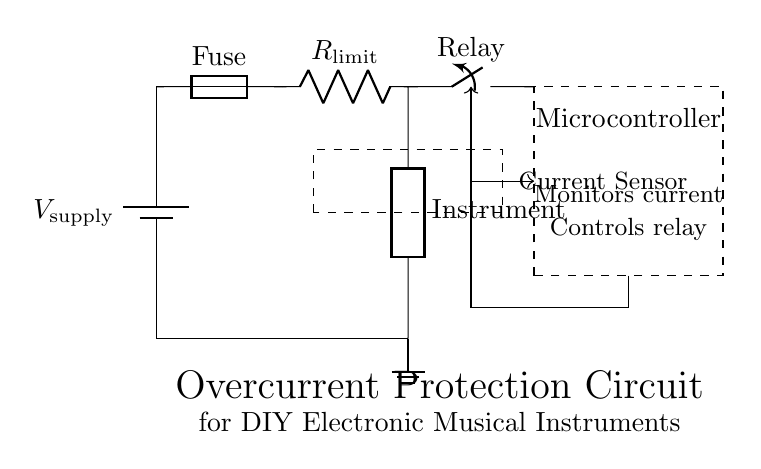What component is used for overcurrent protection? The component used for overcurrent protection in this circuit is a fuse. It is designed to blow when the current exceeds a certain limit, thus protecting the downstream components from excessive current.
Answer: Fuse What is the purpose of the current-limiting resistor? The purpose of the current-limiting resistor is to restrict the amount of current that can flow through the circuit, thereby preventing damage to the connected instrument during normal operation.
Answer: Restrict current Which component monitors the current in the circuit? The component that monitors the current in the circuit is the microcontroller. It receives data from the current sensor and can make decisions based on that data, such as operating the relay.
Answer: Microcontroller What is the role of the relay in this circuit? The relay acts as a switch that can disconnect the circuit from the supply voltage when an overcurrent condition is detected. This is controlled by the microcontroller, which receives inputs from the current sensor.
Answer: Switch How is the microcontroller powered? The microcontroller is powered by the supply voltage in this circuit. It is connected to the same voltage source as the rest of the circuit, ensuring that it has the necessary power to operate.
Answer: Supply voltage What connects the current sensor to the microcontroller? A control line connects the current sensor to the microcontroller, allowing the current data to be transmitted for monitoring and decision-making. The connection is represented by an arrow indicating the direction of signal flow.
Answer: Control line What does the dashed box represent around the current sensor? The dashed box around the current sensor indicates that it is a distinct functional unit within the circuit, isolating it visually to highlight its role in monitoring current levels before they reach other components.
Answer: Current sensor 